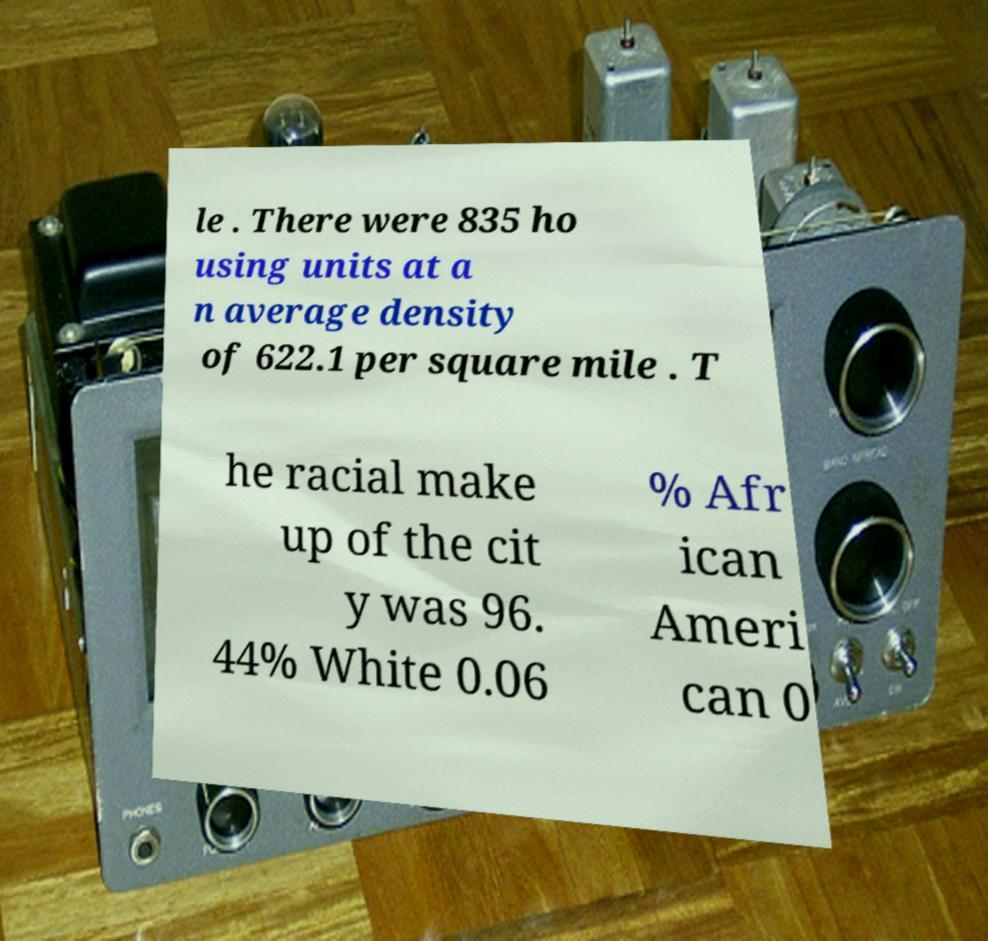Can you read and provide the text displayed in the image?This photo seems to have some interesting text. Can you extract and type it out for me? le . There were 835 ho using units at a n average density of 622.1 per square mile . T he racial make up of the cit y was 96. 44% White 0.06 % Afr ican Ameri can 0 